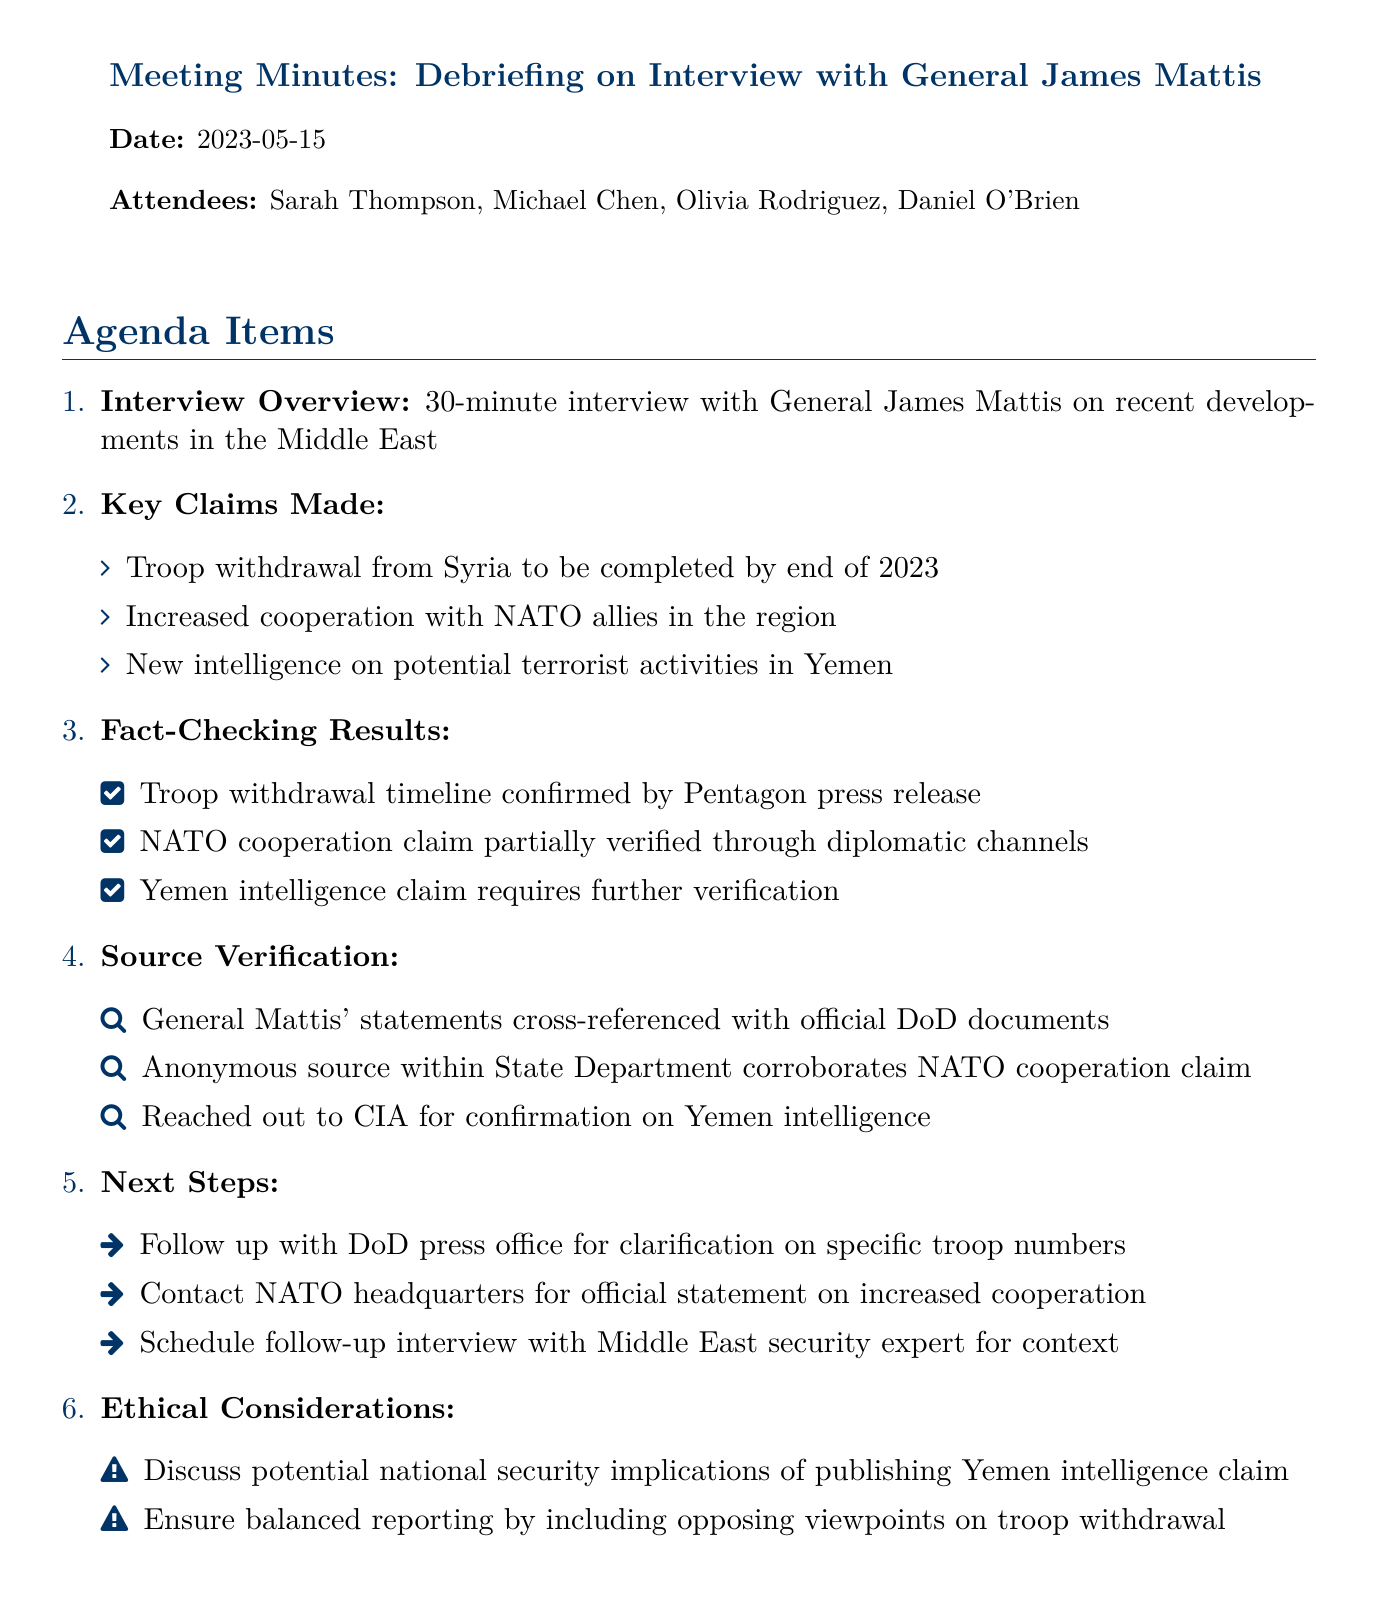What is the title of the meeting? The title of the meeting is stated at the beginning of the document.
Answer: Debriefing on Interview with General James Mattis Who is the main interviewee in the document? The main interviewee is mentioned in the title and in the key claims section.
Answer: General James Mattis What is the date of the meeting? The date is provided clearly in the document.
Answer: 2023-05-15 How many attendees were present at the meeting? The number of attendees can be calculated from the list provided.
Answer: 4 What claim requires further verification? This claim is specifically noted in the fact-checking results section.
Answer: Yemen intelligence claim Which organization's press release confirmed the troop withdrawal timeline? The organization responsible for the confirmation is specified in the document.
Answer: Pentagon What is one of the next steps mentioned in the meeting? This is listed in the Next Steps section of the agenda items.
Answer: Follow up with DoD press office What ethical consideration is mentioned regarding Yemen intelligence? This ethical consideration is highlighted in the ethical considerations section.
Answer: Discuss potential national security implications What is one method used for source verification? The method of source verification is detailed in that specific section.
Answer: Cross-referenced with official DoD documents 